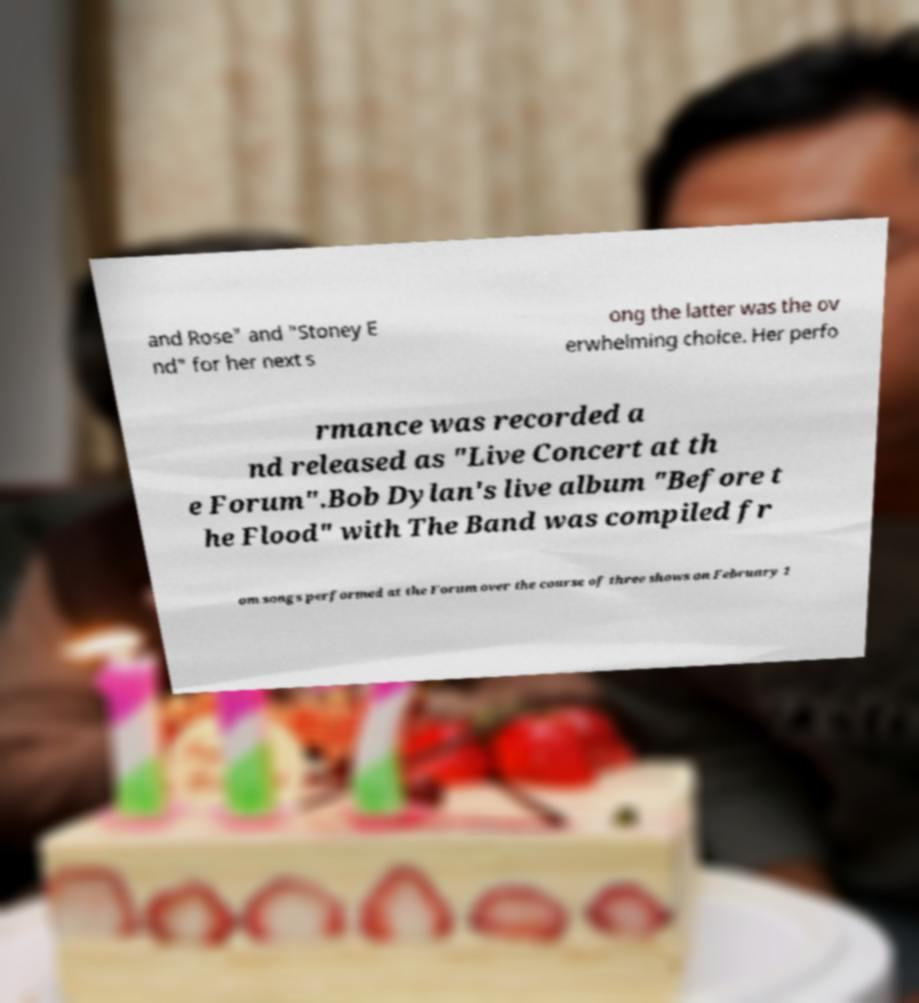I need the written content from this picture converted into text. Can you do that? and Rose" and "Stoney E nd" for her next s ong the latter was the ov erwhelming choice. Her perfo rmance was recorded a nd released as "Live Concert at th e Forum".Bob Dylan's live album "Before t he Flood" with The Band was compiled fr om songs performed at the Forum over the course of three shows on February 1 